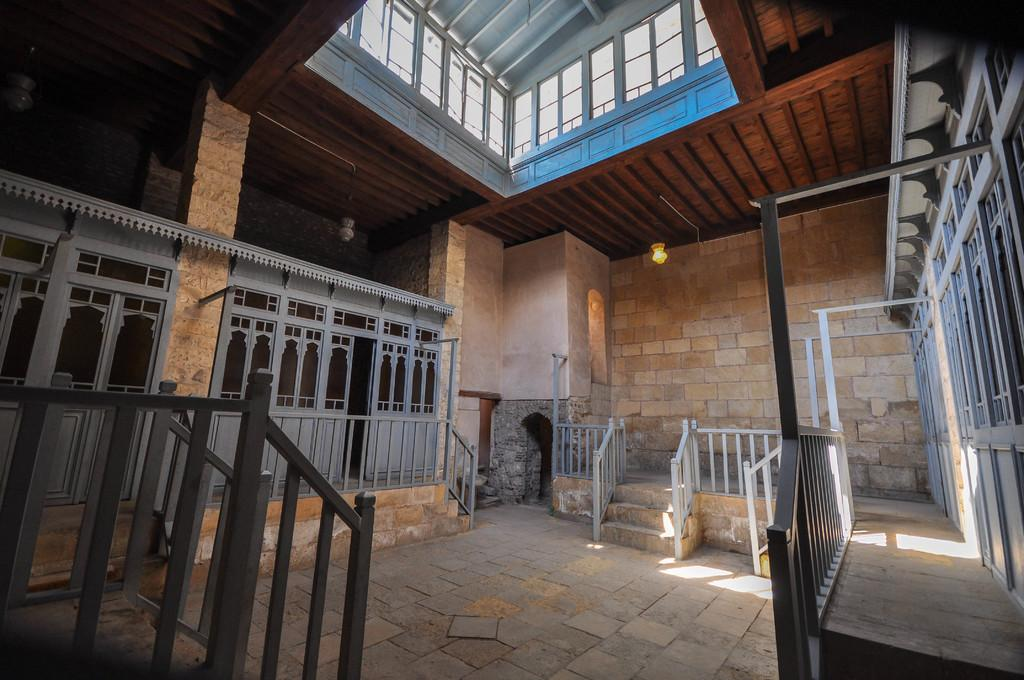What type of location is depicted in the image? The image is an inside view of a building. What architectural feature can be seen in the image? There is a fence in the image. What is the source of light in the image? There is a light in the image. What structural element is present in the image? There is a pillar in the image. What can be used for moving between different levels in the building? There are steps in the image. What surface is visible in the image? The image shows a floor. What separates different areas within the building? There is a wall in the image. How many trucks are parked near the wall in the image? There are no trucks present in the image; it is an inside view of a building with various architectural and structural elements. 